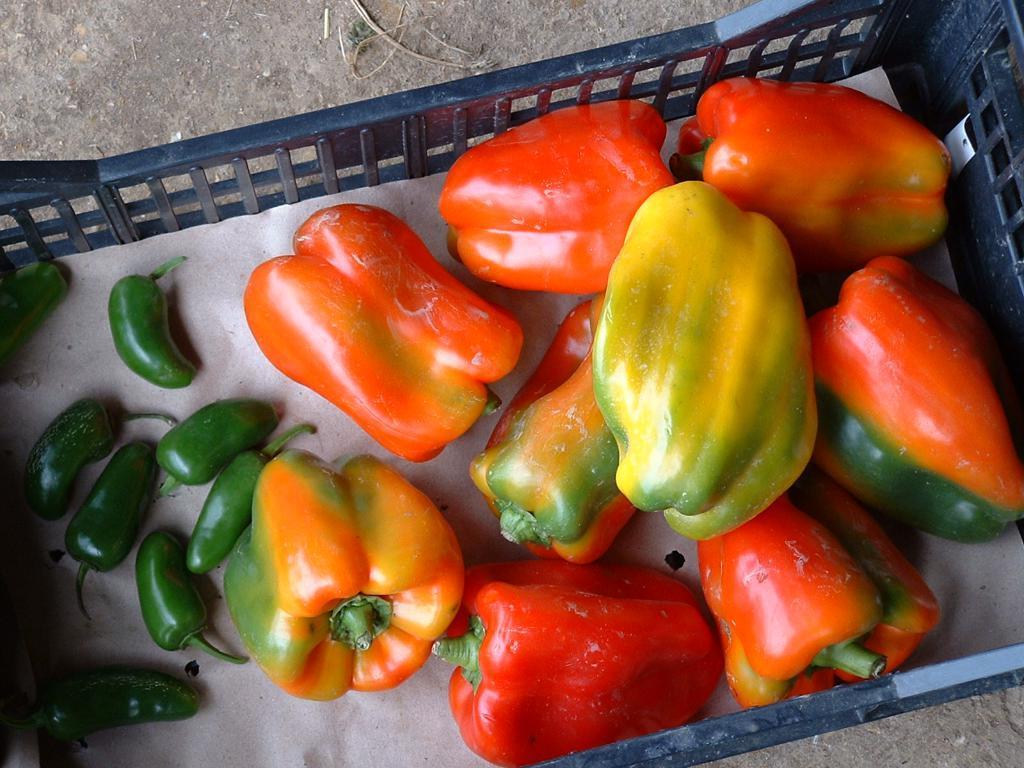Can you describe this image briefly? The picture consists of capsicums, chillies, tray, pad, floor and other objects. 